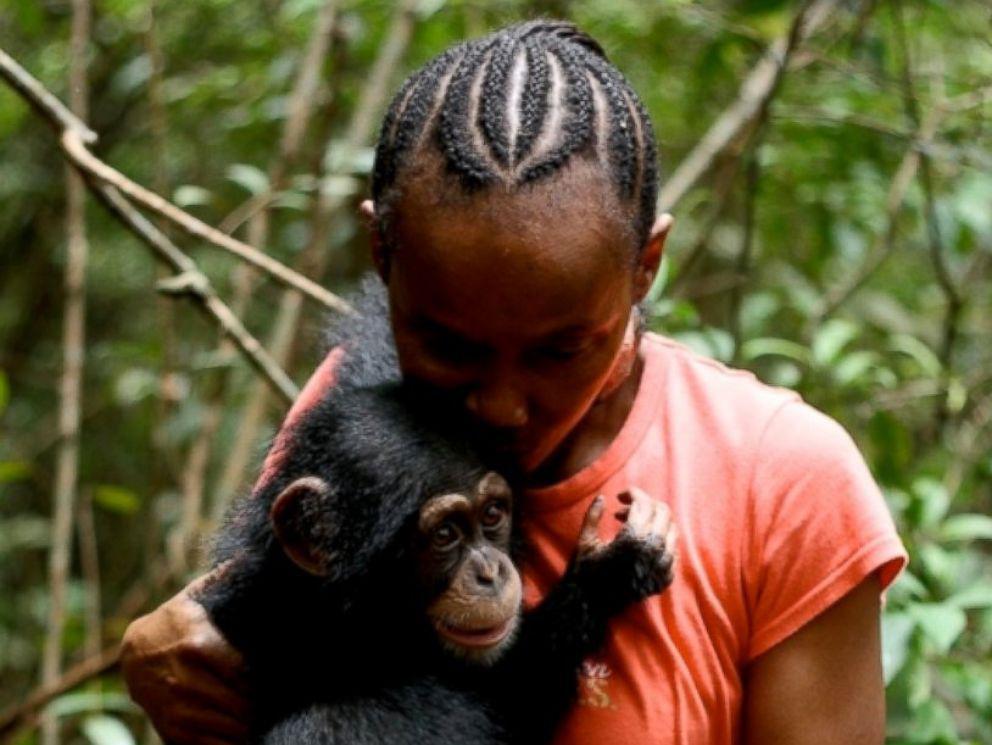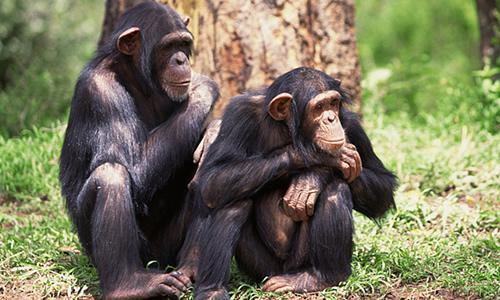The first image is the image on the left, the second image is the image on the right. Analyze the images presented: Is the assertion "An image shows one adult chimp next to a baby chimp, with both faces visible." valid? Answer yes or no. No. 